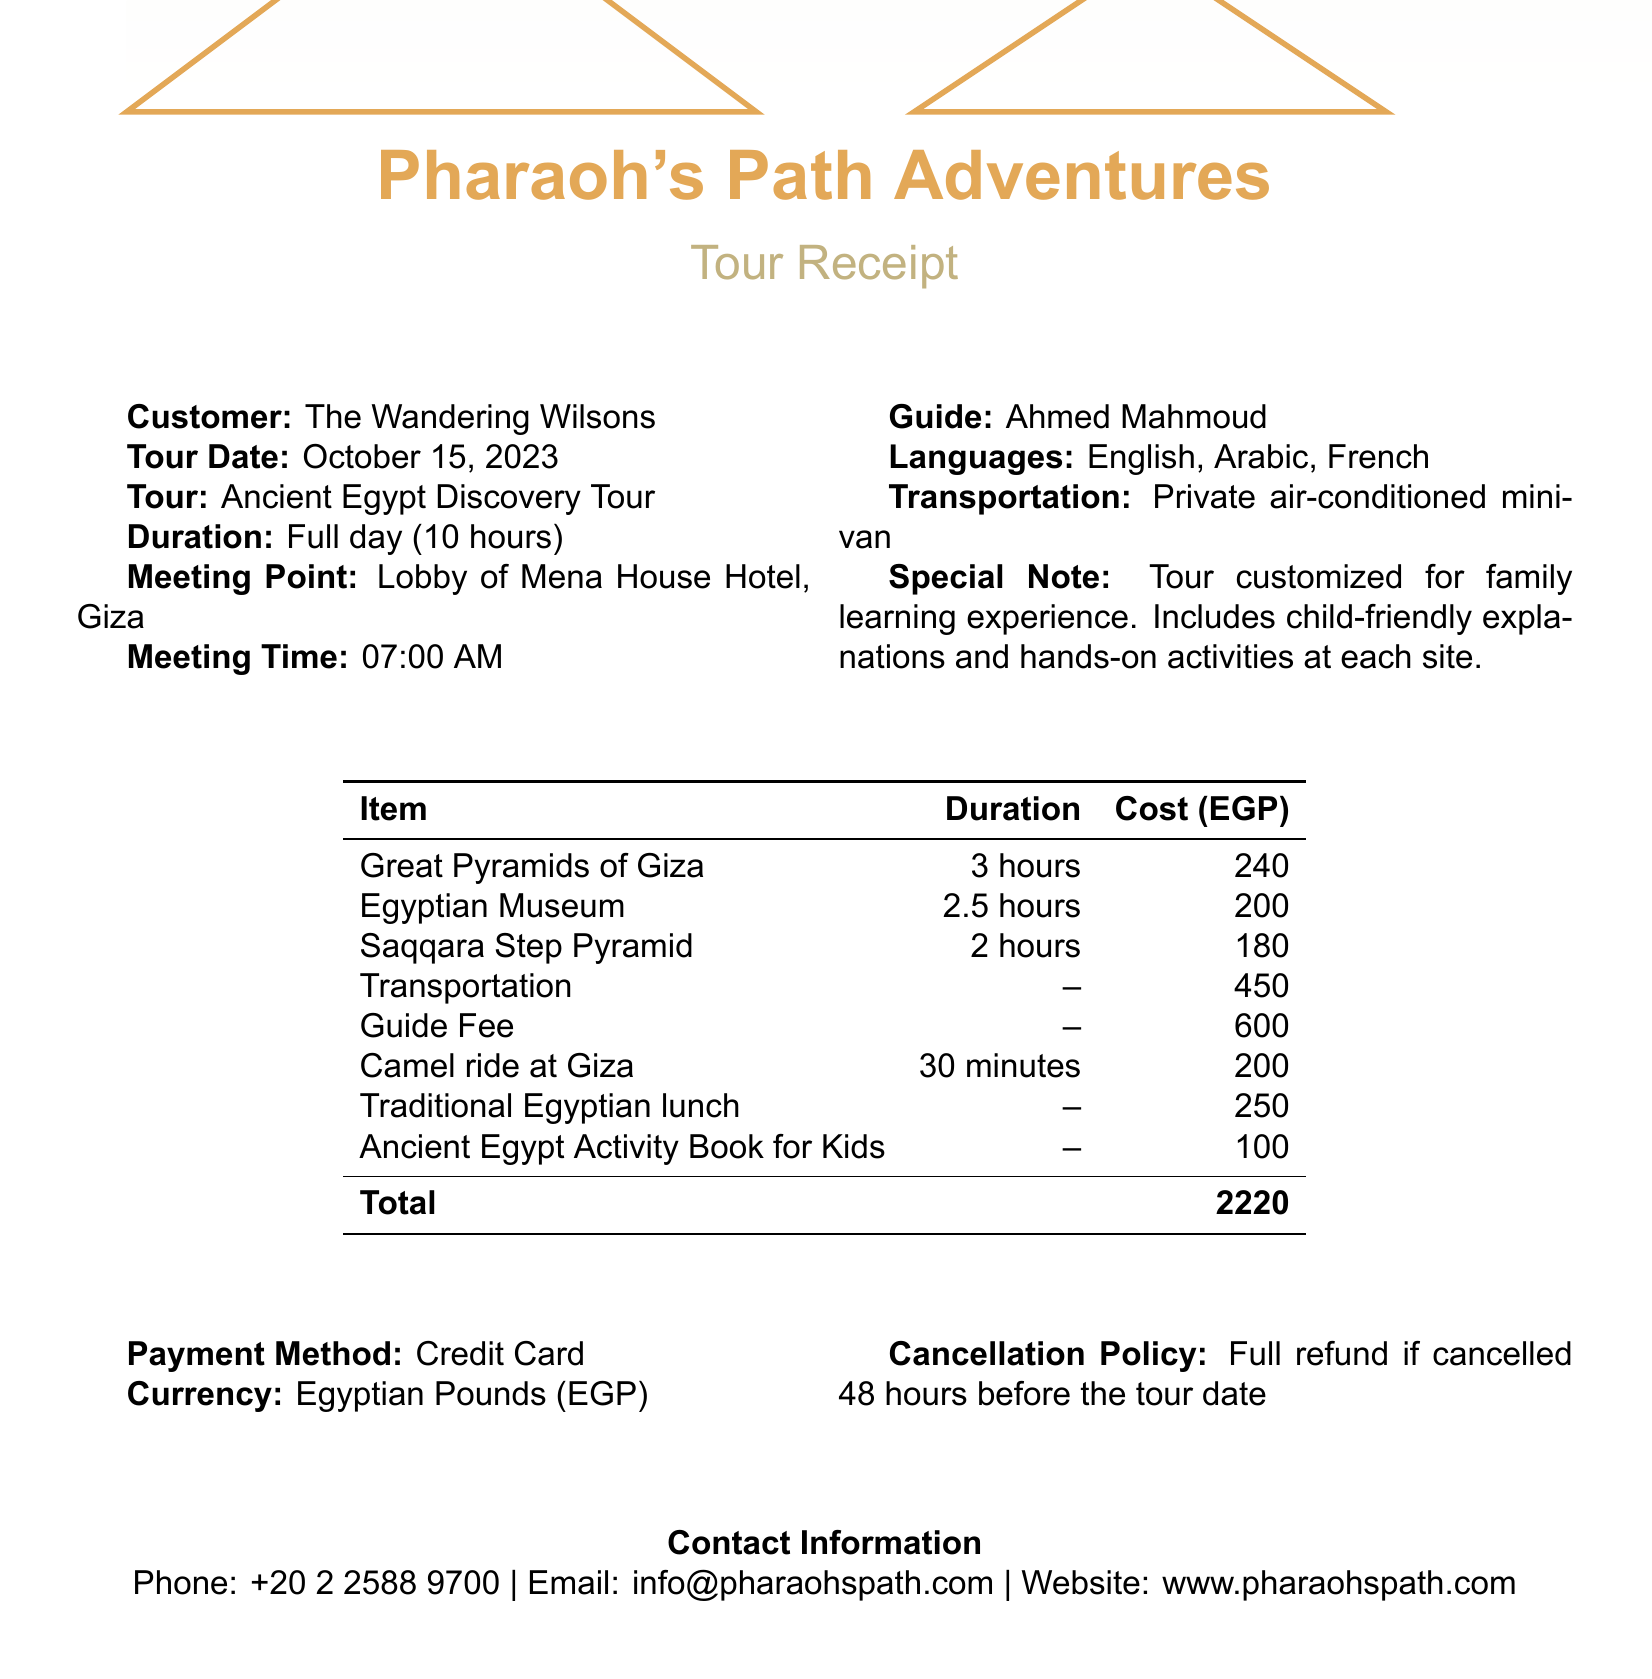What is the name of the tour operator? The name of the tour operator can be found in the section detailing the organization offering the tour.
Answer: Pharaoh's Path Adventures What is the total cost of the tour? The total cost is mentioned at the end of the receipts, after all individual costs are listed.
Answer: 2220 What is the meeting time for the tour? The meeting time for the tour is specified in the tour details section of the document.
Answer: 07:00 AM What type of transportation is provided? The type of transportation is noted under the transportation section in the document.
Answer: Private air-conditioned minivan How long is the tour? The duration of the tour is provided in the tour details section.
Answer: Full day (10 hours) What is the entrance fee for the Egyptian Museum? The entrance fee is listed for each site in the itinerary section.
Answer: 200 What special note is included in the document? The special note can be found in the details about the tour, highlighting its customization.
Answer: Tour customized for family learning experience. Includes child-friendly explanations and hands-on activities at each site What is the cancellation policy for the tour? The cancellation policy is presented toward the end of the document, detailing conditions for refunds.
Answer: Full refund if cancelled 48 hours before the tour date What language(s) does the guide speak? The languages spoken by the guide are mentioned in the guide details section.
Answer: English, Arabic, French 